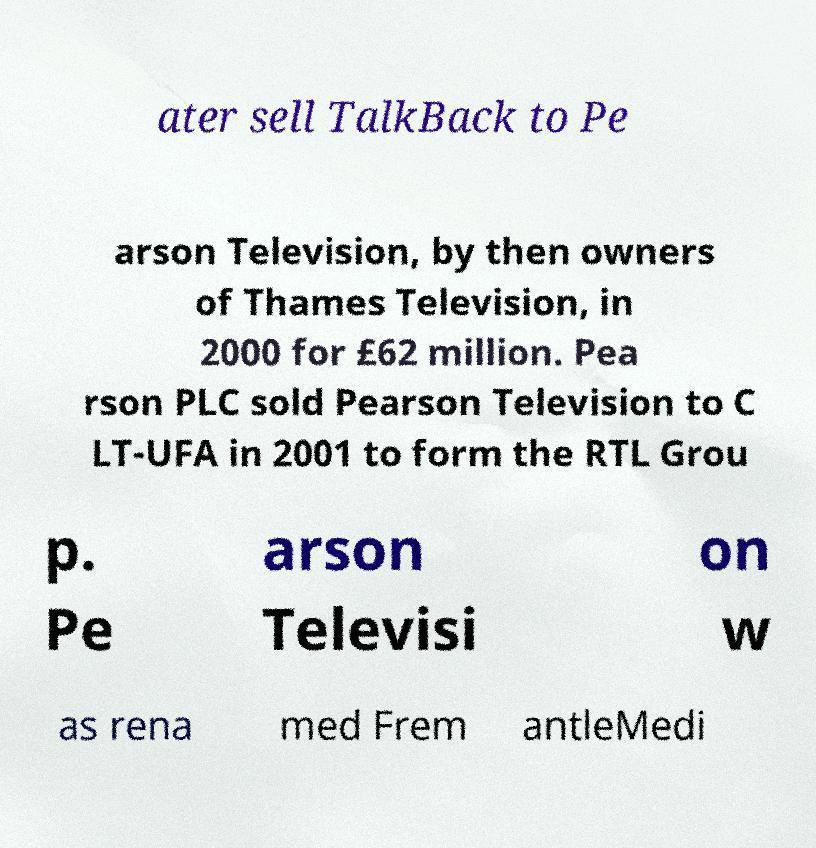Can you read and provide the text displayed in the image?This photo seems to have some interesting text. Can you extract and type it out for me? ater sell TalkBack to Pe arson Television, by then owners of Thames Television, in 2000 for £62 million. Pea rson PLC sold Pearson Television to C LT-UFA in 2001 to form the RTL Grou p. Pe arson Televisi on w as rena med Frem antleMedi 